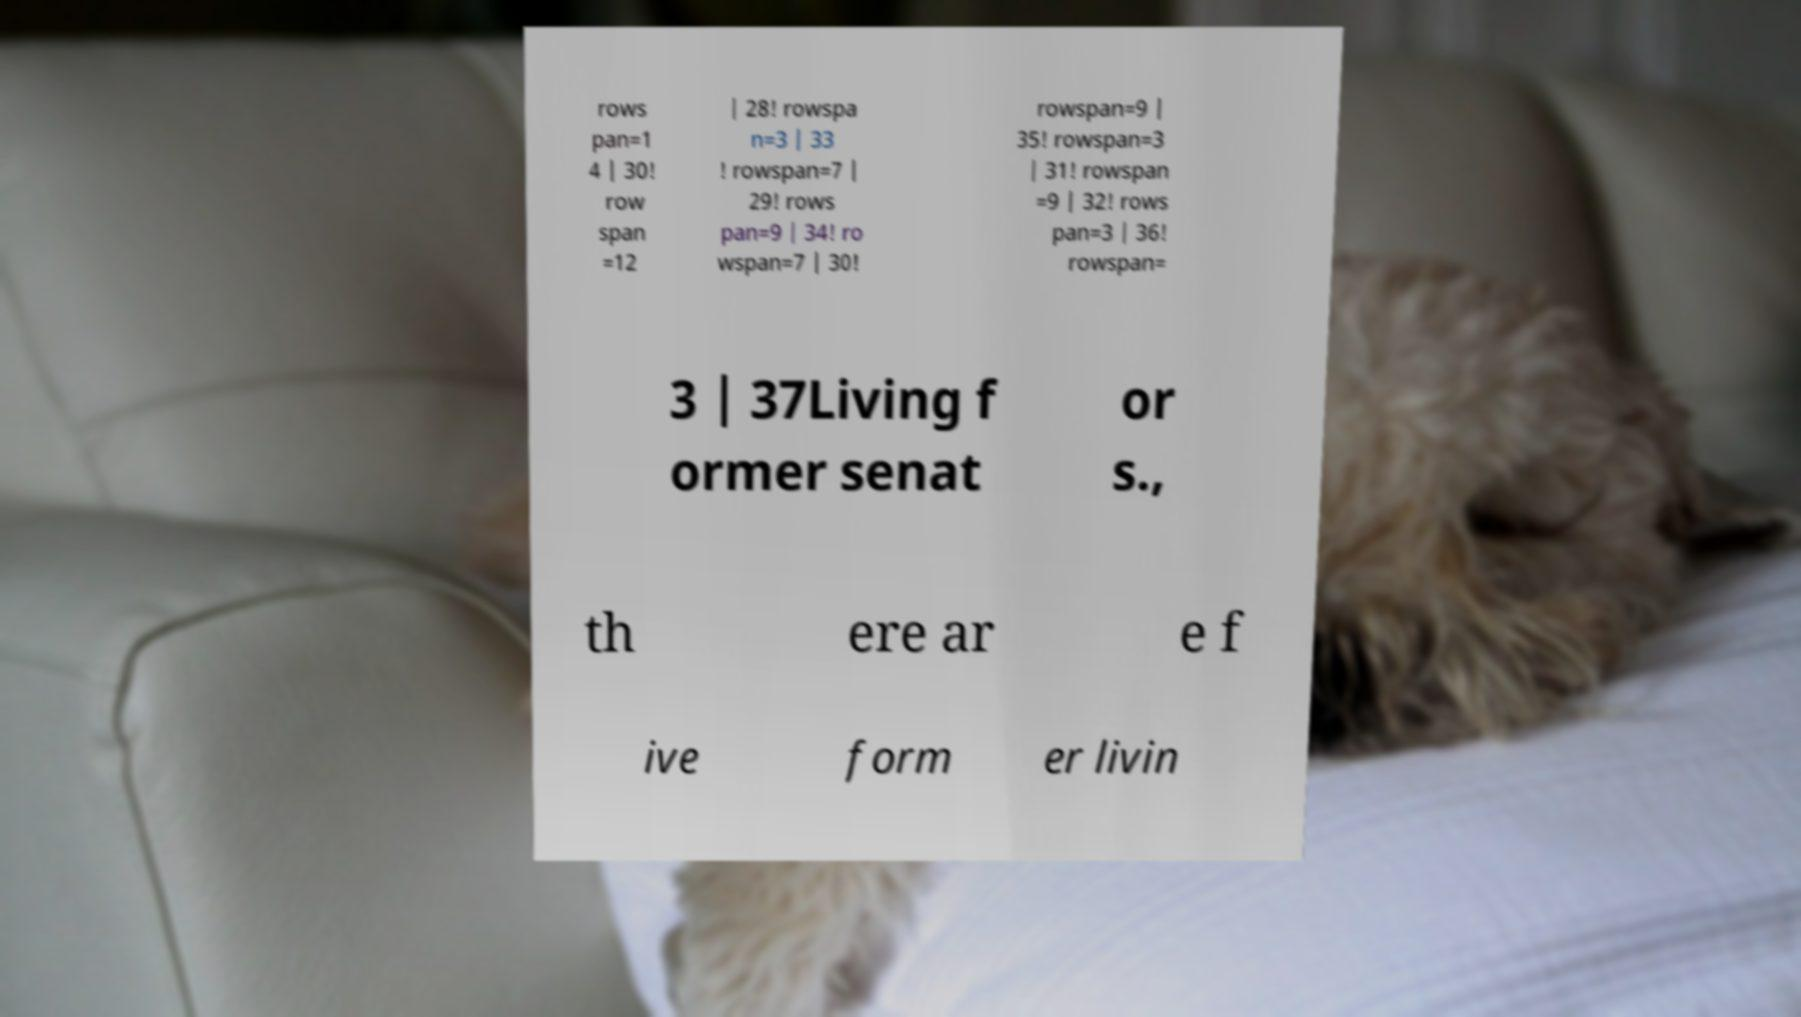Please read and relay the text visible in this image. What does it say? rows pan=1 4 | 30! row span =12 | 28! rowspa n=3 | 33 ! rowspan=7 | 29! rows pan=9 | 34! ro wspan=7 | 30! rowspan=9 | 35! rowspan=3 | 31! rowspan =9 | 32! rows pan=3 | 36! rowspan= 3 | 37Living f ormer senat or s., th ere ar e f ive form er livin 